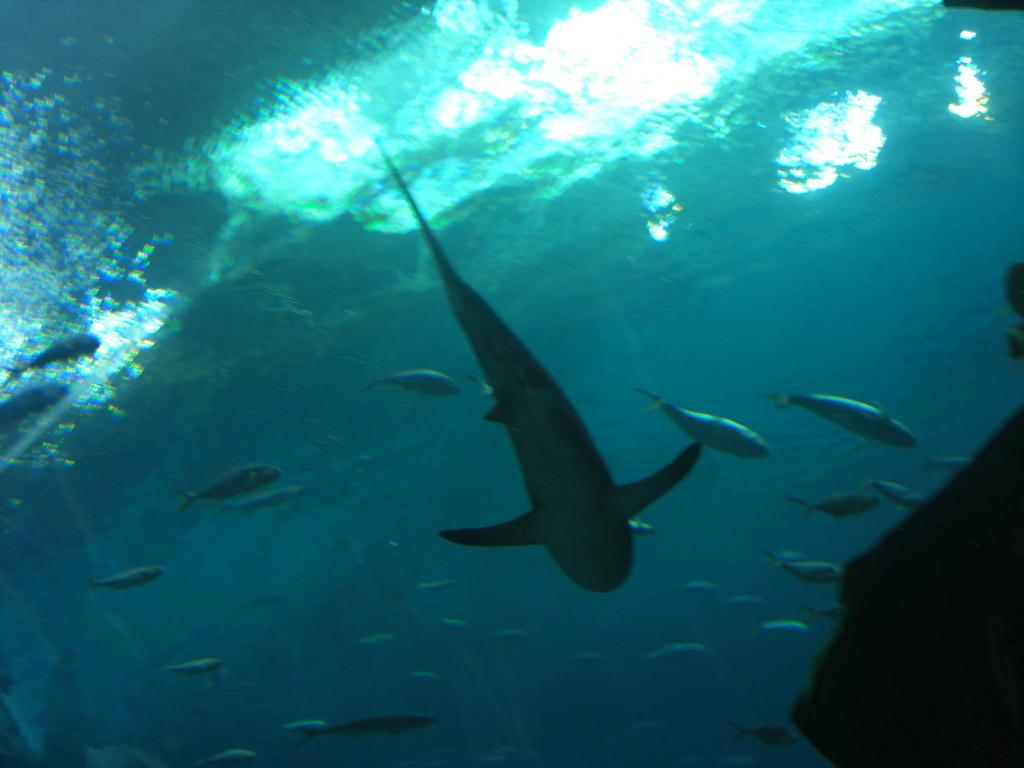What type of animals can be seen in the image? There are fishes in the image. Where are the fishes located? The fishes are in the water. What type of surprise can be seen on the chin of the fish in the image? There is no surprise or chin present on the fish in the image, as fish do not have chins or the ability to express surprise. 